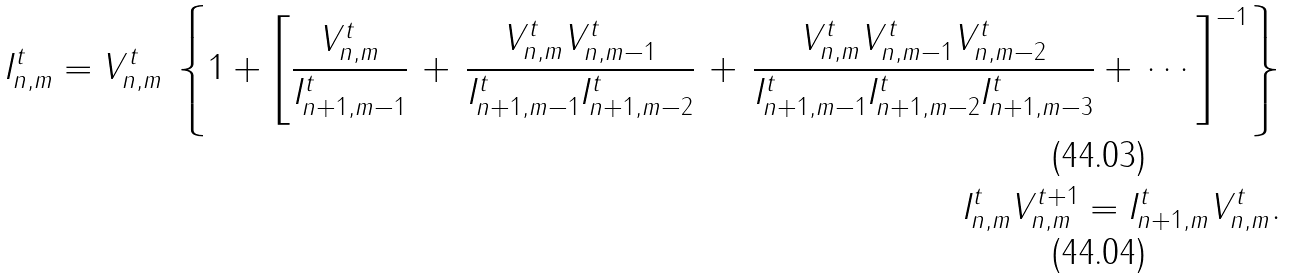Convert formula to latex. <formula><loc_0><loc_0><loc_500><loc_500>I _ { n , m } ^ { t } = V _ { n , m } ^ { t } \, \left \{ 1 + { \left [ \frac { V _ { n , m } ^ { t } } { I _ { n + 1 , m - 1 } ^ { t } } \, + \, \frac { V _ { n , m } ^ { t } V _ { n , m - 1 } ^ { t } } { I _ { n + 1 , m - 1 } ^ { t } I _ { n + 1 , m - 2 } ^ { t } } \, + \, \frac { V _ { n , m } ^ { t } V _ { n , m - 1 } ^ { t } V _ { n , m - 2 } ^ { t } } { I _ { n + 1 , m - 1 } ^ { t } I _ { n + 1 , m - 2 } ^ { t } I _ { n + 1 , m - 3 } ^ { t } } + \, \cdots \right ] ^ { - 1 } } \right \} \\ I _ { n , m } ^ { t } V _ { n , m } ^ { t + 1 } = I _ { n + 1 , m } ^ { t } V _ { n , m } ^ { t } .</formula> 